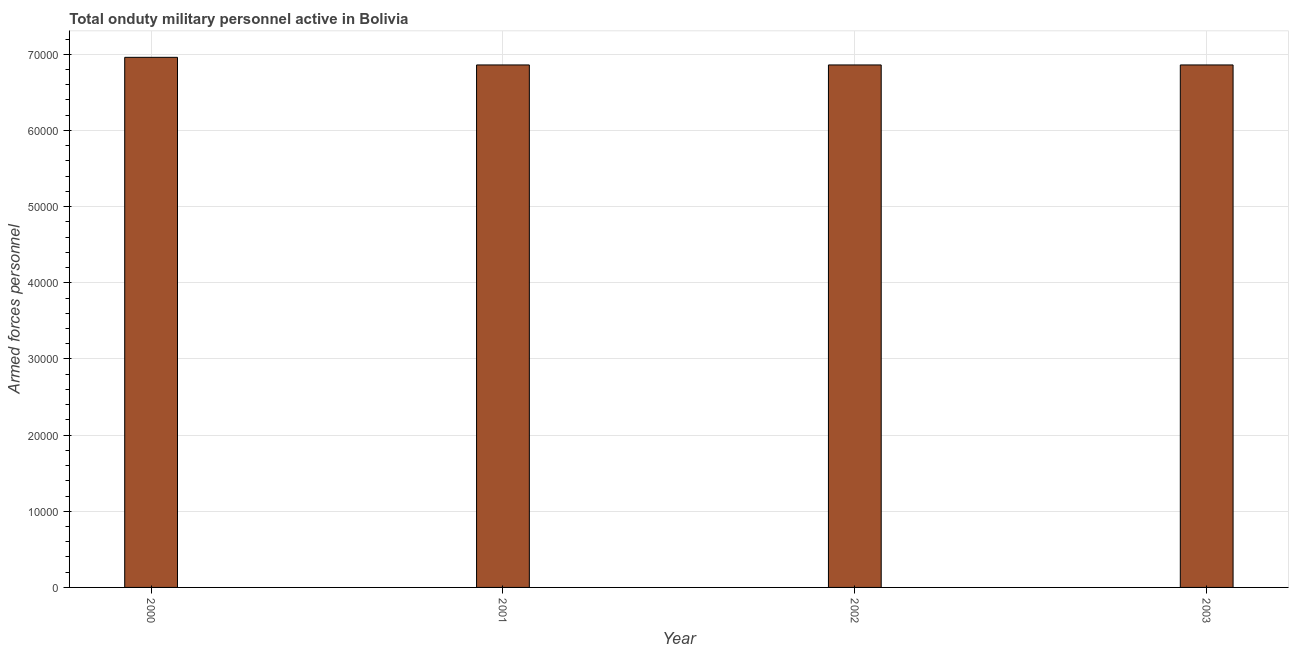Does the graph contain any zero values?
Ensure brevity in your answer.  No. What is the title of the graph?
Offer a terse response. Total onduty military personnel active in Bolivia. What is the label or title of the X-axis?
Keep it short and to the point. Year. What is the label or title of the Y-axis?
Offer a very short reply. Armed forces personnel. What is the number of armed forces personnel in 2002?
Offer a very short reply. 6.86e+04. Across all years, what is the maximum number of armed forces personnel?
Give a very brief answer. 6.96e+04. Across all years, what is the minimum number of armed forces personnel?
Keep it short and to the point. 6.86e+04. In which year was the number of armed forces personnel minimum?
Offer a very short reply. 2001. What is the sum of the number of armed forces personnel?
Keep it short and to the point. 2.75e+05. What is the average number of armed forces personnel per year?
Keep it short and to the point. 6.88e+04. What is the median number of armed forces personnel?
Your response must be concise. 6.86e+04. In how many years, is the number of armed forces personnel greater than 24000 ?
Your response must be concise. 4. Do a majority of the years between 2003 and 2000 (inclusive) have number of armed forces personnel greater than 52000 ?
Your answer should be very brief. Yes. What is the ratio of the number of armed forces personnel in 2000 to that in 2001?
Your answer should be compact. 1.01. Is the difference between the number of armed forces personnel in 2000 and 2003 greater than the difference between any two years?
Your answer should be very brief. Yes. What is the difference between the highest and the second highest number of armed forces personnel?
Offer a terse response. 1000. Is the sum of the number of armed forces personnel in 2001 and 2003 greater than the maximum number of armed forces personnel across all years?
Offer a very short reply. Yes. What is the difference between the highest and the lowest number of armed forces personnel?
Keep it short and to the point. 1000. How many bars are there?
Offer a very short reply. 4. What is the Armed forces personnel in 2000?
Make the answer very short. 6.96e+04. What is the Armed forces personnel in 2001?
Offer a terse response. 6.86e+04. What is the Armed forces personnel of 2002?
Offer a terse response. 6.86e+04. What is the Armed forces personnel in 2003?
Keep it short and to the point. 6.86e+04. What is the difference between the Armed forces personnel in 2001 and 2002?
Your answer should be compact. 0. What is the difference between the Armed forces personnel in 2001 and 2003?
Offer a very short reply. 0. What is the difference between the Armed forces personnel in 2002 and 2003?
Your answer should be compact. 0. 